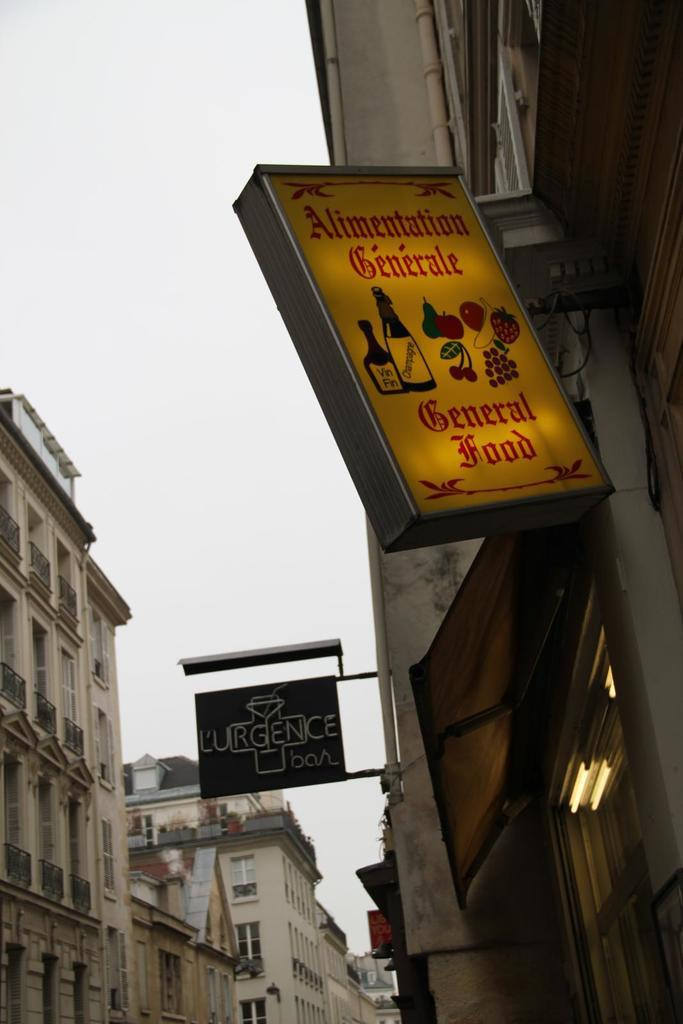<image>
Describe the image concisely. A lit up sign denoting a place for General Food or Alimentation Generale. 